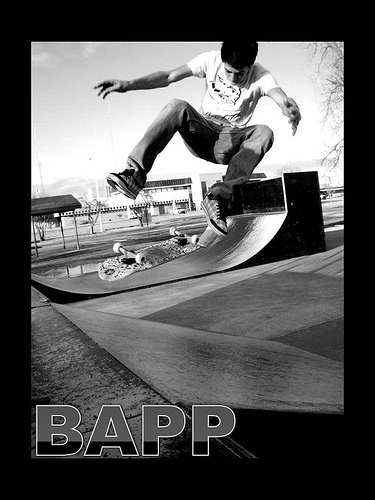World skate is the head controller of which sport?
A. surfing
B. swimming
C. skiing
D. skating
Answer with the option's letter from the given choices directly. D 